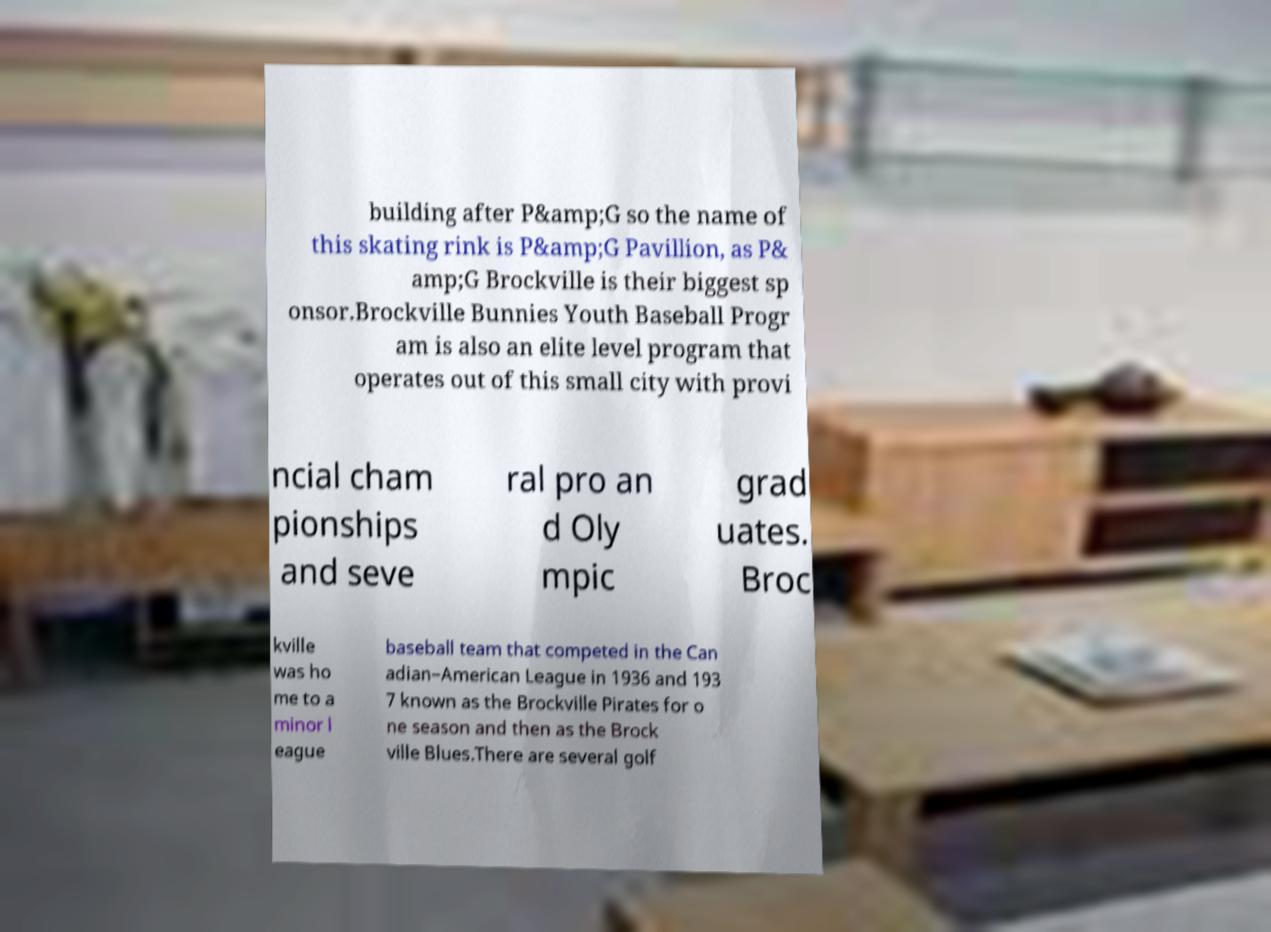Can you accurately transcribe the text from the provided image for me? building after P&amp;G so the name of this skating rink is P&amp;G Pavillion, as P& amp;G Brockville is their biggest sp onsor.Brockville Bunnies Youth Baseball Progr am is also an elite level program that operates out of this small city with provi ncial cham pionships and seve ral pro an d Oly mpic grad uates. Broc kville was ho me to a minor l eague baseball team that competed in the Can adian–American League in 1936 and 193 7 known as the Brockville Pirates for o ne season and then as the Brock ville Blues.There are several golf 